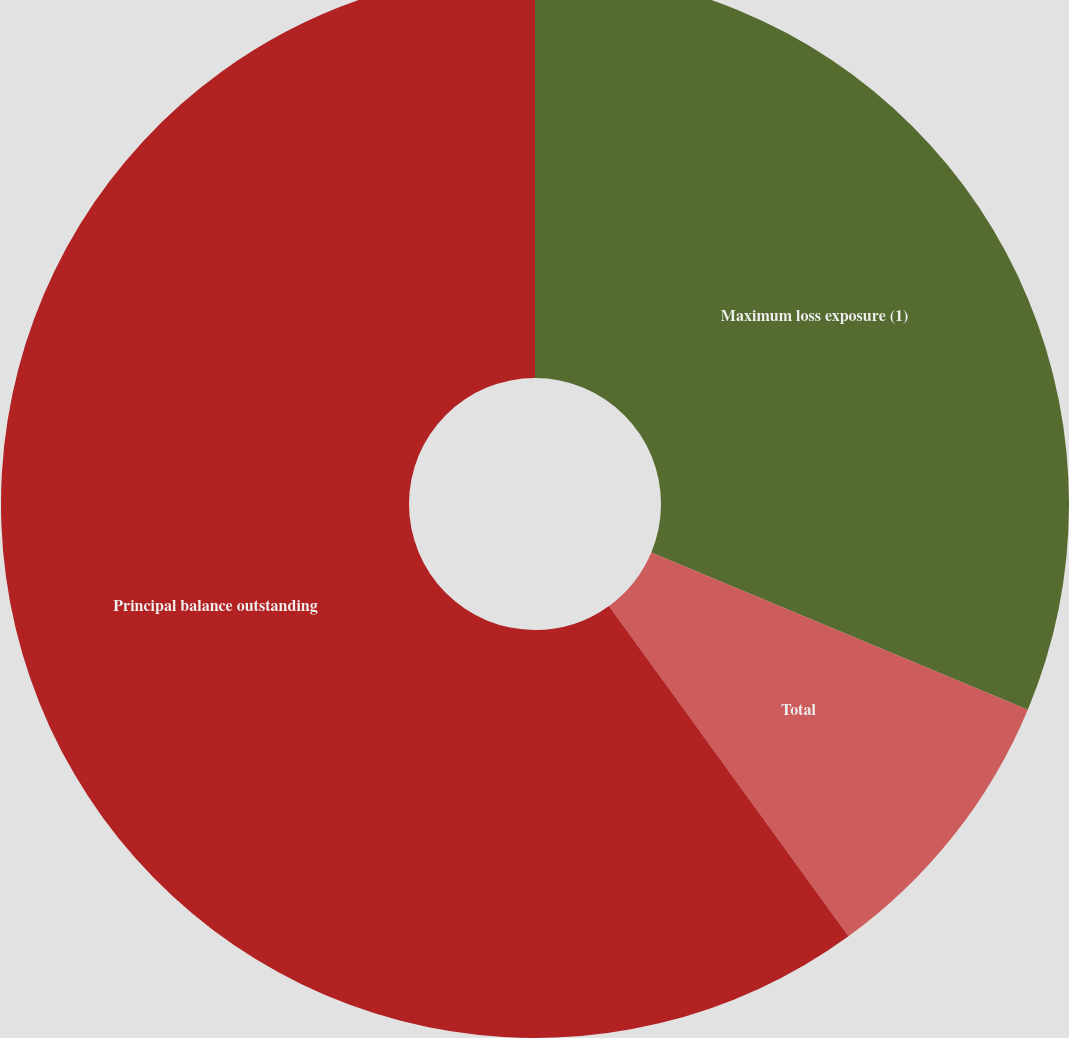Convert chart to OTSL. <chart><loc_0><loc_0><loc_500><loc_500><pie_chart><fcel>Maximum loss exposure (1)<fcel>Total<fcel>Principal balance outstanding<nl><fcel>31.29%<fcel>8.72%<fcel>59.98%<nl></chart> 